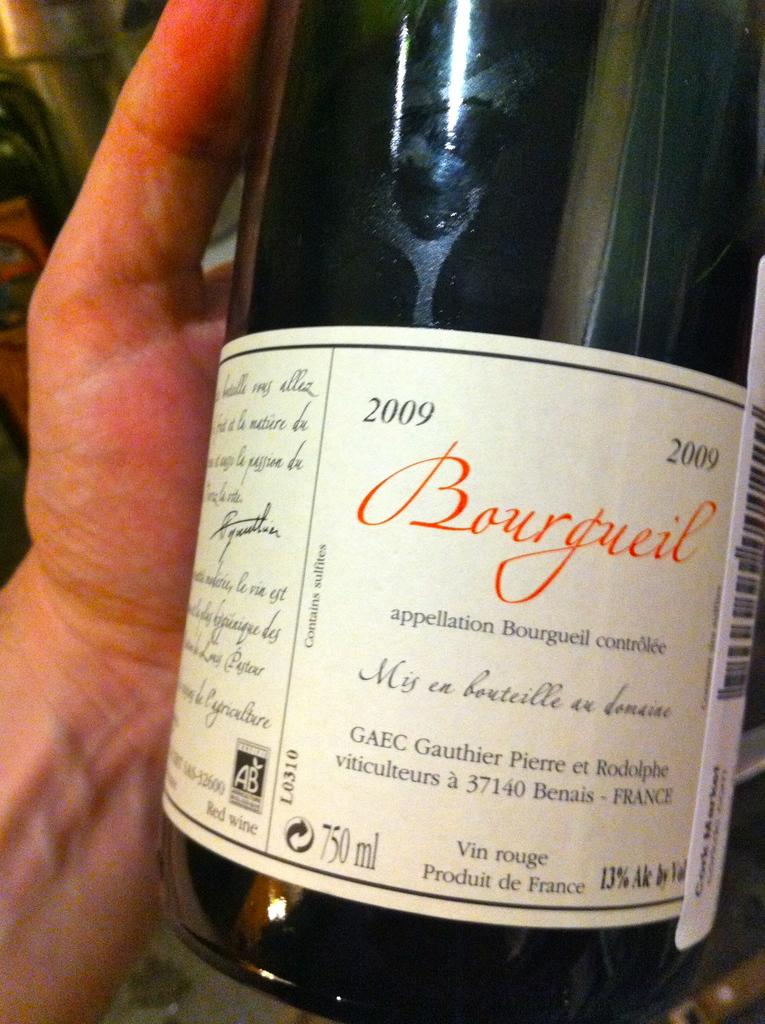<image>
Create a compact narrative representing the image presented. A person is holding a bottle of alcohol from the brand Bourgreil. 